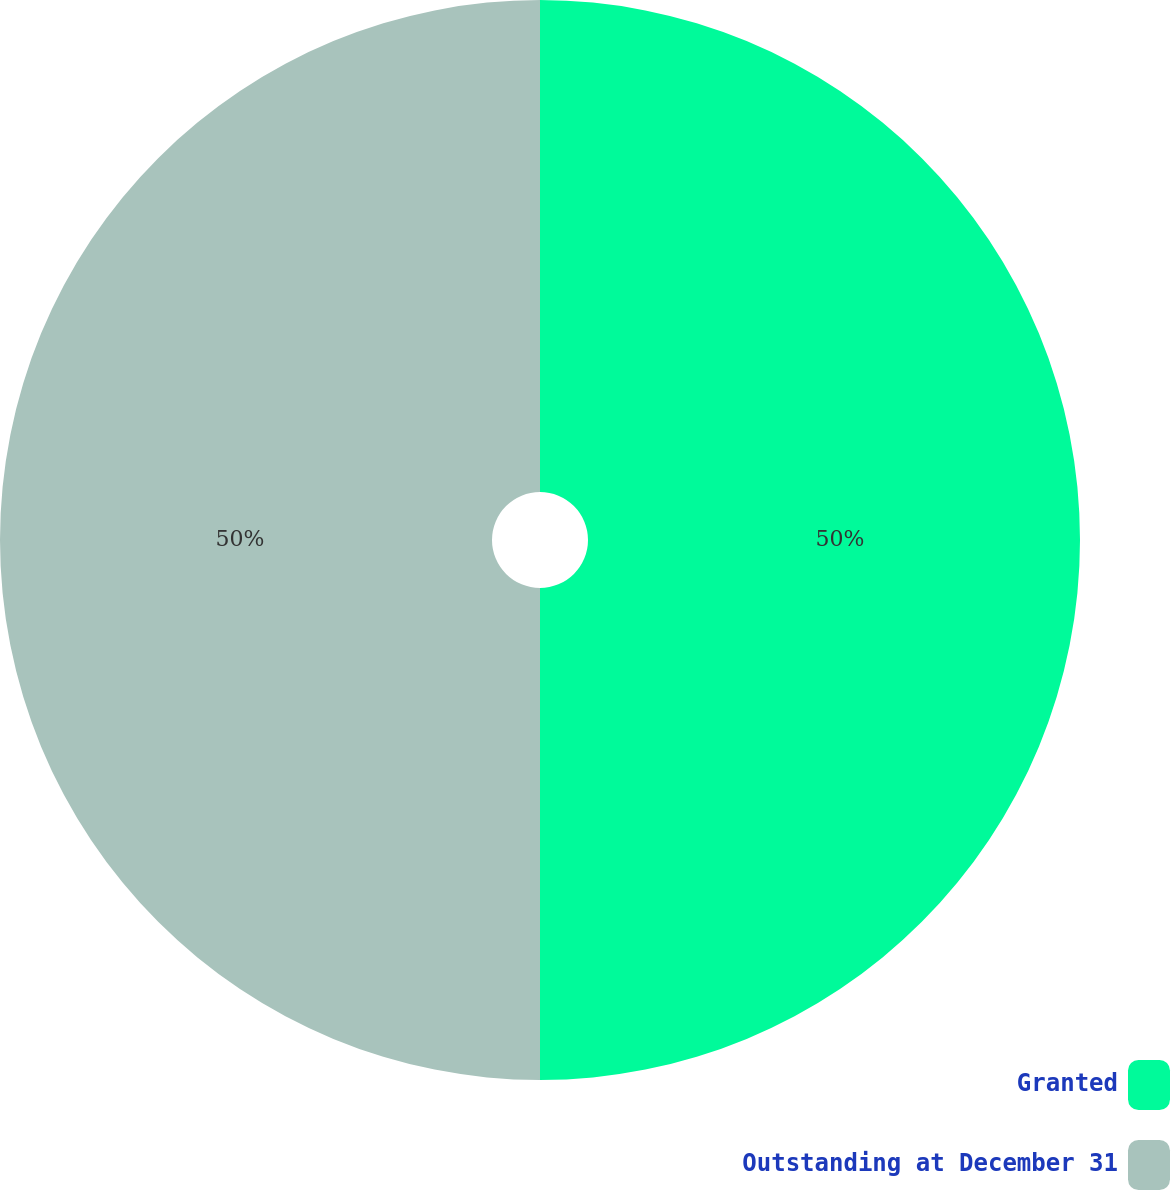<chart> <loc_0><loc_0><loc_500><loc_500><pie_chart><fcel>Granted<fcel>Outstanding at December 31<nl><fcel>50.0%<fcel>50.0%<nl></chart> 